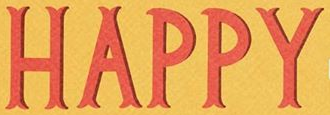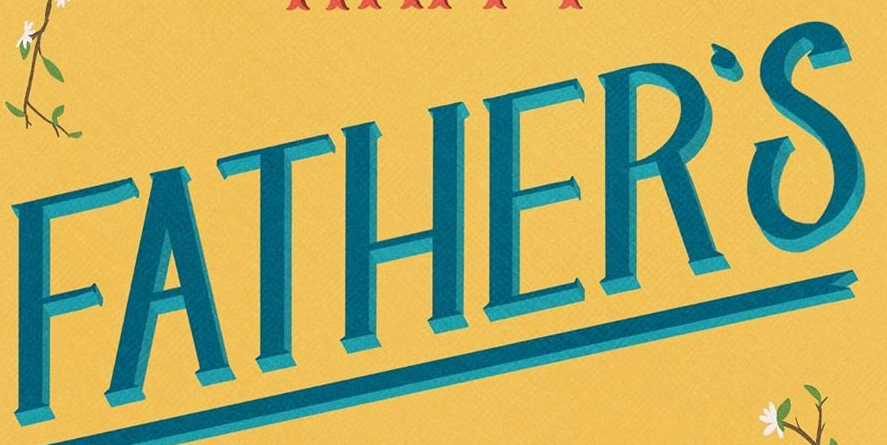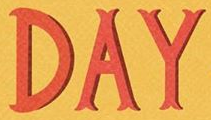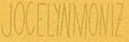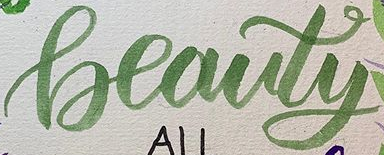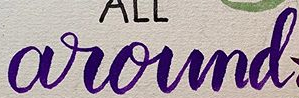Read the text content from these images in order, separated by a semicolon. HAPPY; FATHER'S; DAY; JOCELYNMONIZ; Beauty; around 